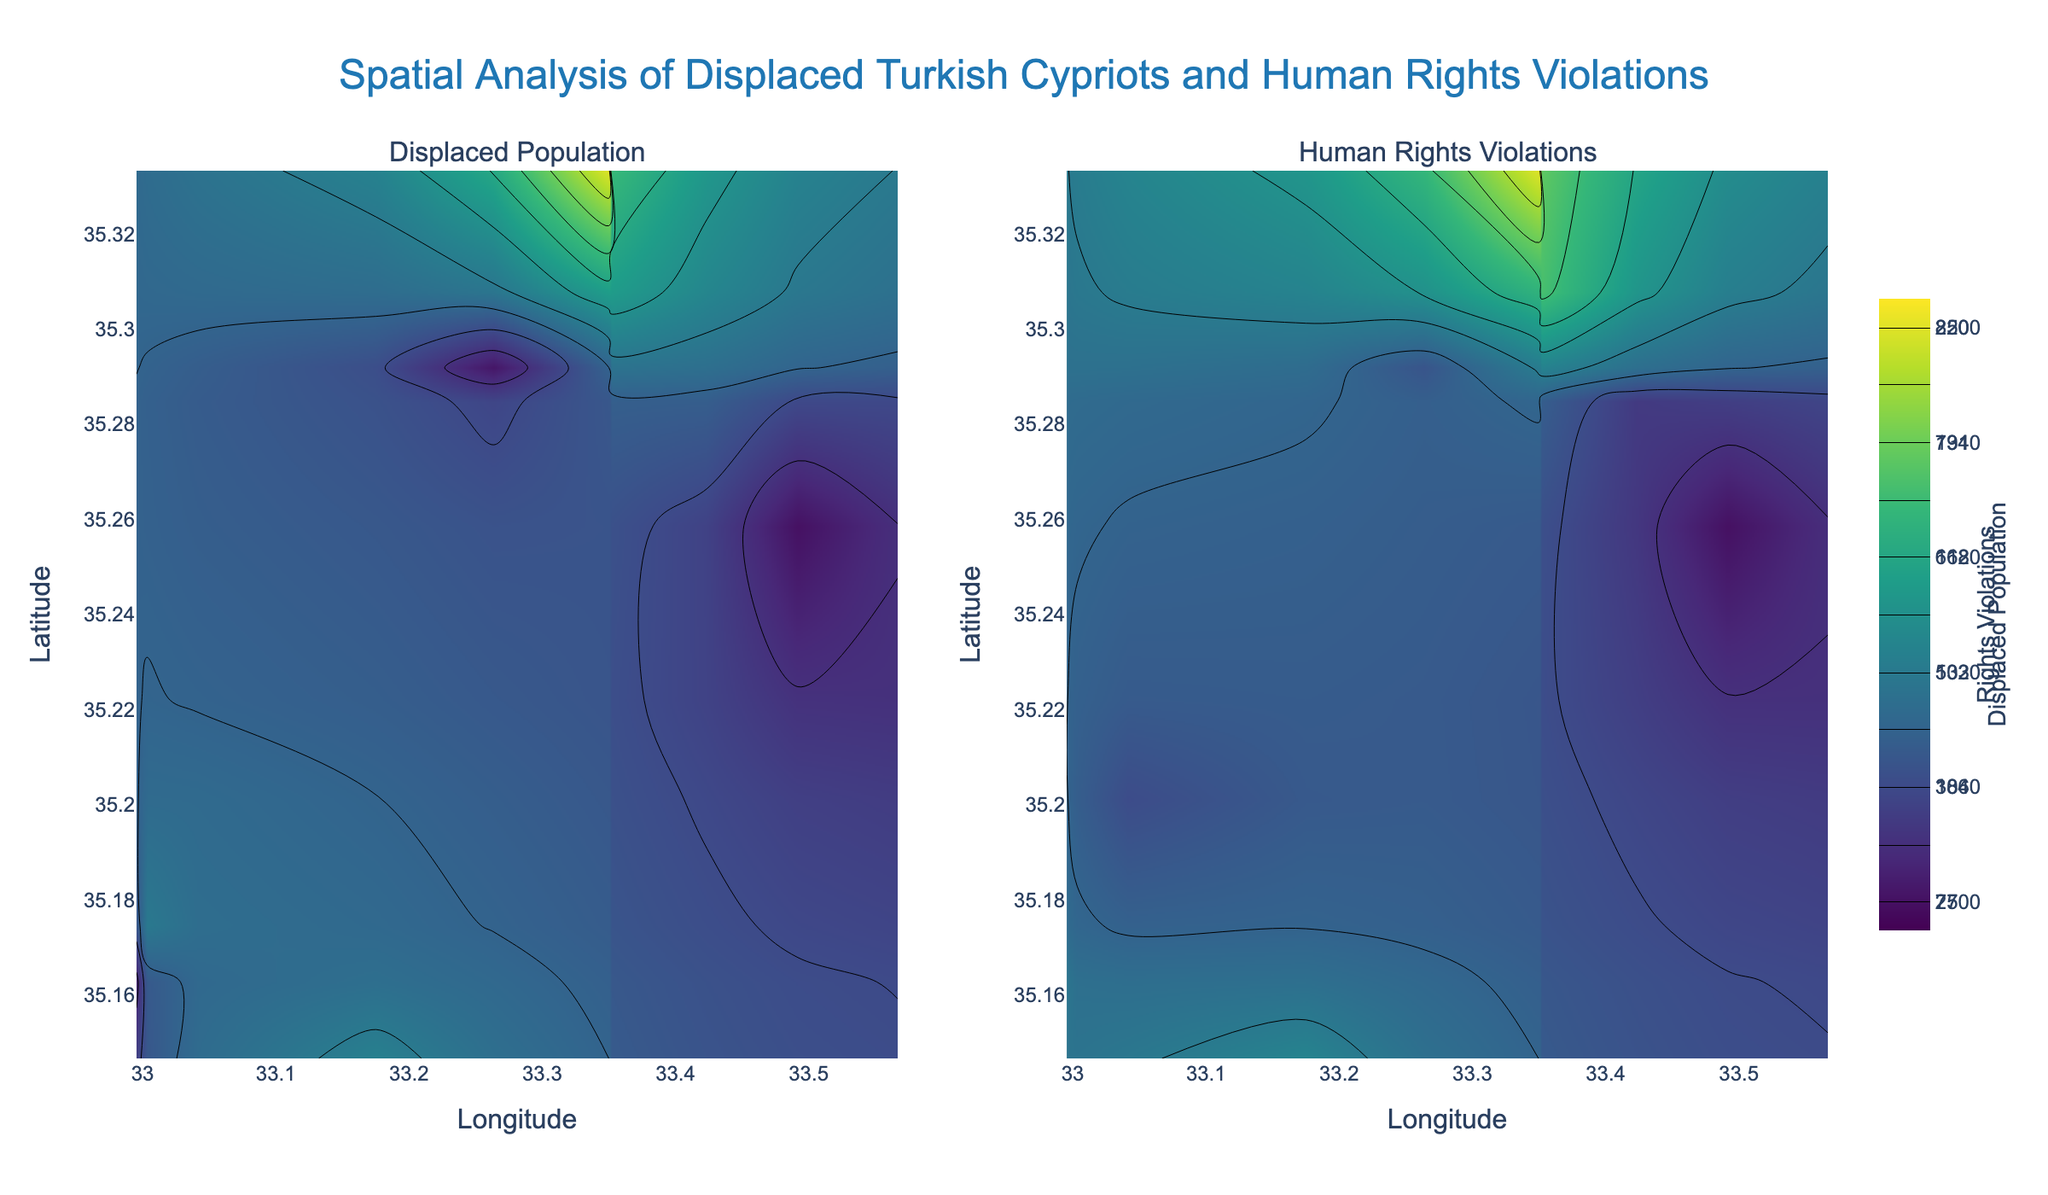What is the title of the plot? The title of the plot is located at the top center of the figure. It is written in a larger font size and in light blue color.
Answer: Spatial Analysis of Displaced Turkish Cypriots and Human Rights Violations What does the x-axis represent in the plot? The x-axis label is written at the bottom of both subplots, and it reads 'Longitude'. This shows that the x-axis represents the longitude coordinates.
Answer: Longitude Which subplot has a title 'Displaced Population'? The subplot titles are written above each subplot. The title 'Displaced Population' is above the subplot on the left.
Answer: The left subplot What is the color scheme used in the contour plots? The contour plots use a 'Viridis' color scale, which goes from dark purple to yellow. This information is available through the distinct gradual color change across the plots.
Answer: Viridis Which location has the highest displacement population in the contour plot? To find the location with the highest displaced population, locate the maximum value area in the left subplot. This area is around longitude 33.35 and latitude 35.33, which corresponds to a displacement population of 8500.
Answer: Longitude 33.35, Latitude 35.3333 How is the human rights violations data distributed across the region? The right subplot provides a heatmap showing the human rights violations. The highest density is observed around longitude 33.35 and latitude 35.33, where it reaches a maximum of 220, indicating a concentrated area of violations.
Answer: Concentrated around Longitude 33.35, Latitude 35.3333 Compare the location with the highest number of displaced populations to the location with the highest number of human rights violations. Both highest displaced population (8500) and highest human rights violations (220) occur around the same location, longitude 33.35 and latitude 35.33. This indicates a significant overlap in these two metrics.
Answer: Overlaps at Longitude 33.35, Latitude 35.3333 Based on the contour plots, is there a correlation between high displaced populations and high rates of human rights violations? By visually comparing both subplots, the highest values for both displaced populations and human rights violations occur in the same geographical region around longitude 33.35 and latitude 35.33. This suggests a positive correlation between the two variables in this region.
Answer: Yes, there is a positive correlation What is the contour value interval used in both the displaced population and human rights violations plots? Both contour plots use intervals calculated by dividing the difference between the maximum and minimum values by 10. For the displaced population, the interval size is (8500 - 2700) / 10 = 580. For human rights violations, the interval is (220 - 75) / 10 = 14.5.
Answer: Displaced Population: 580, Human Rights Violations: 14.5 